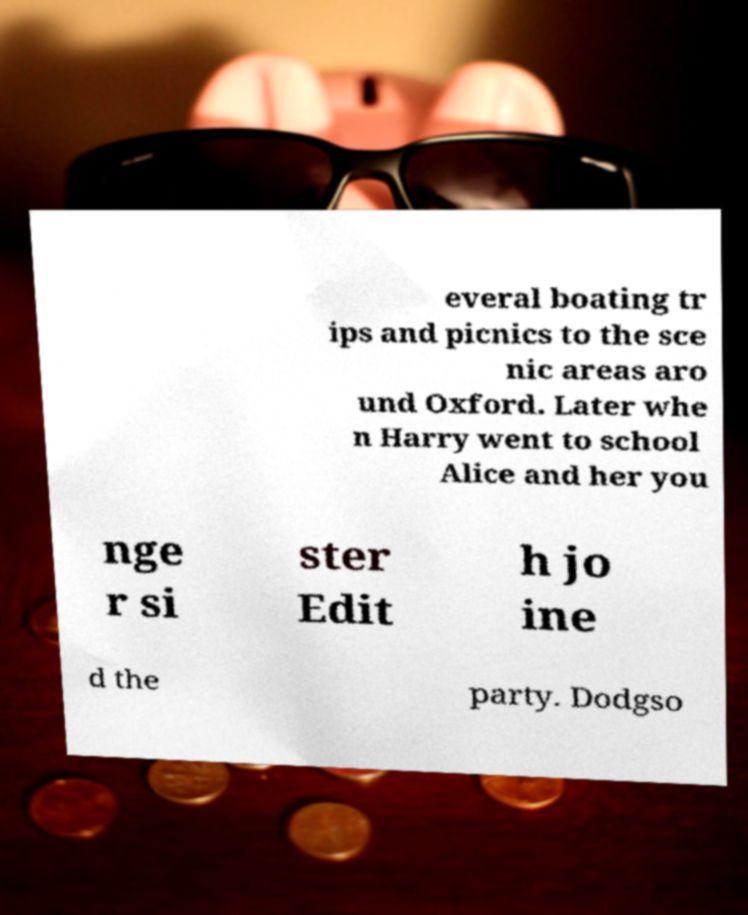There's text embedded in this image that I need extracted. Can you transcribe it verbatim? everal boating tr ips and picnics to the sce nic areas aro und Oxford. Later whe n Harry went to school Alice and her you nge r si ster Edit h jo ine d the party. Dodgso 